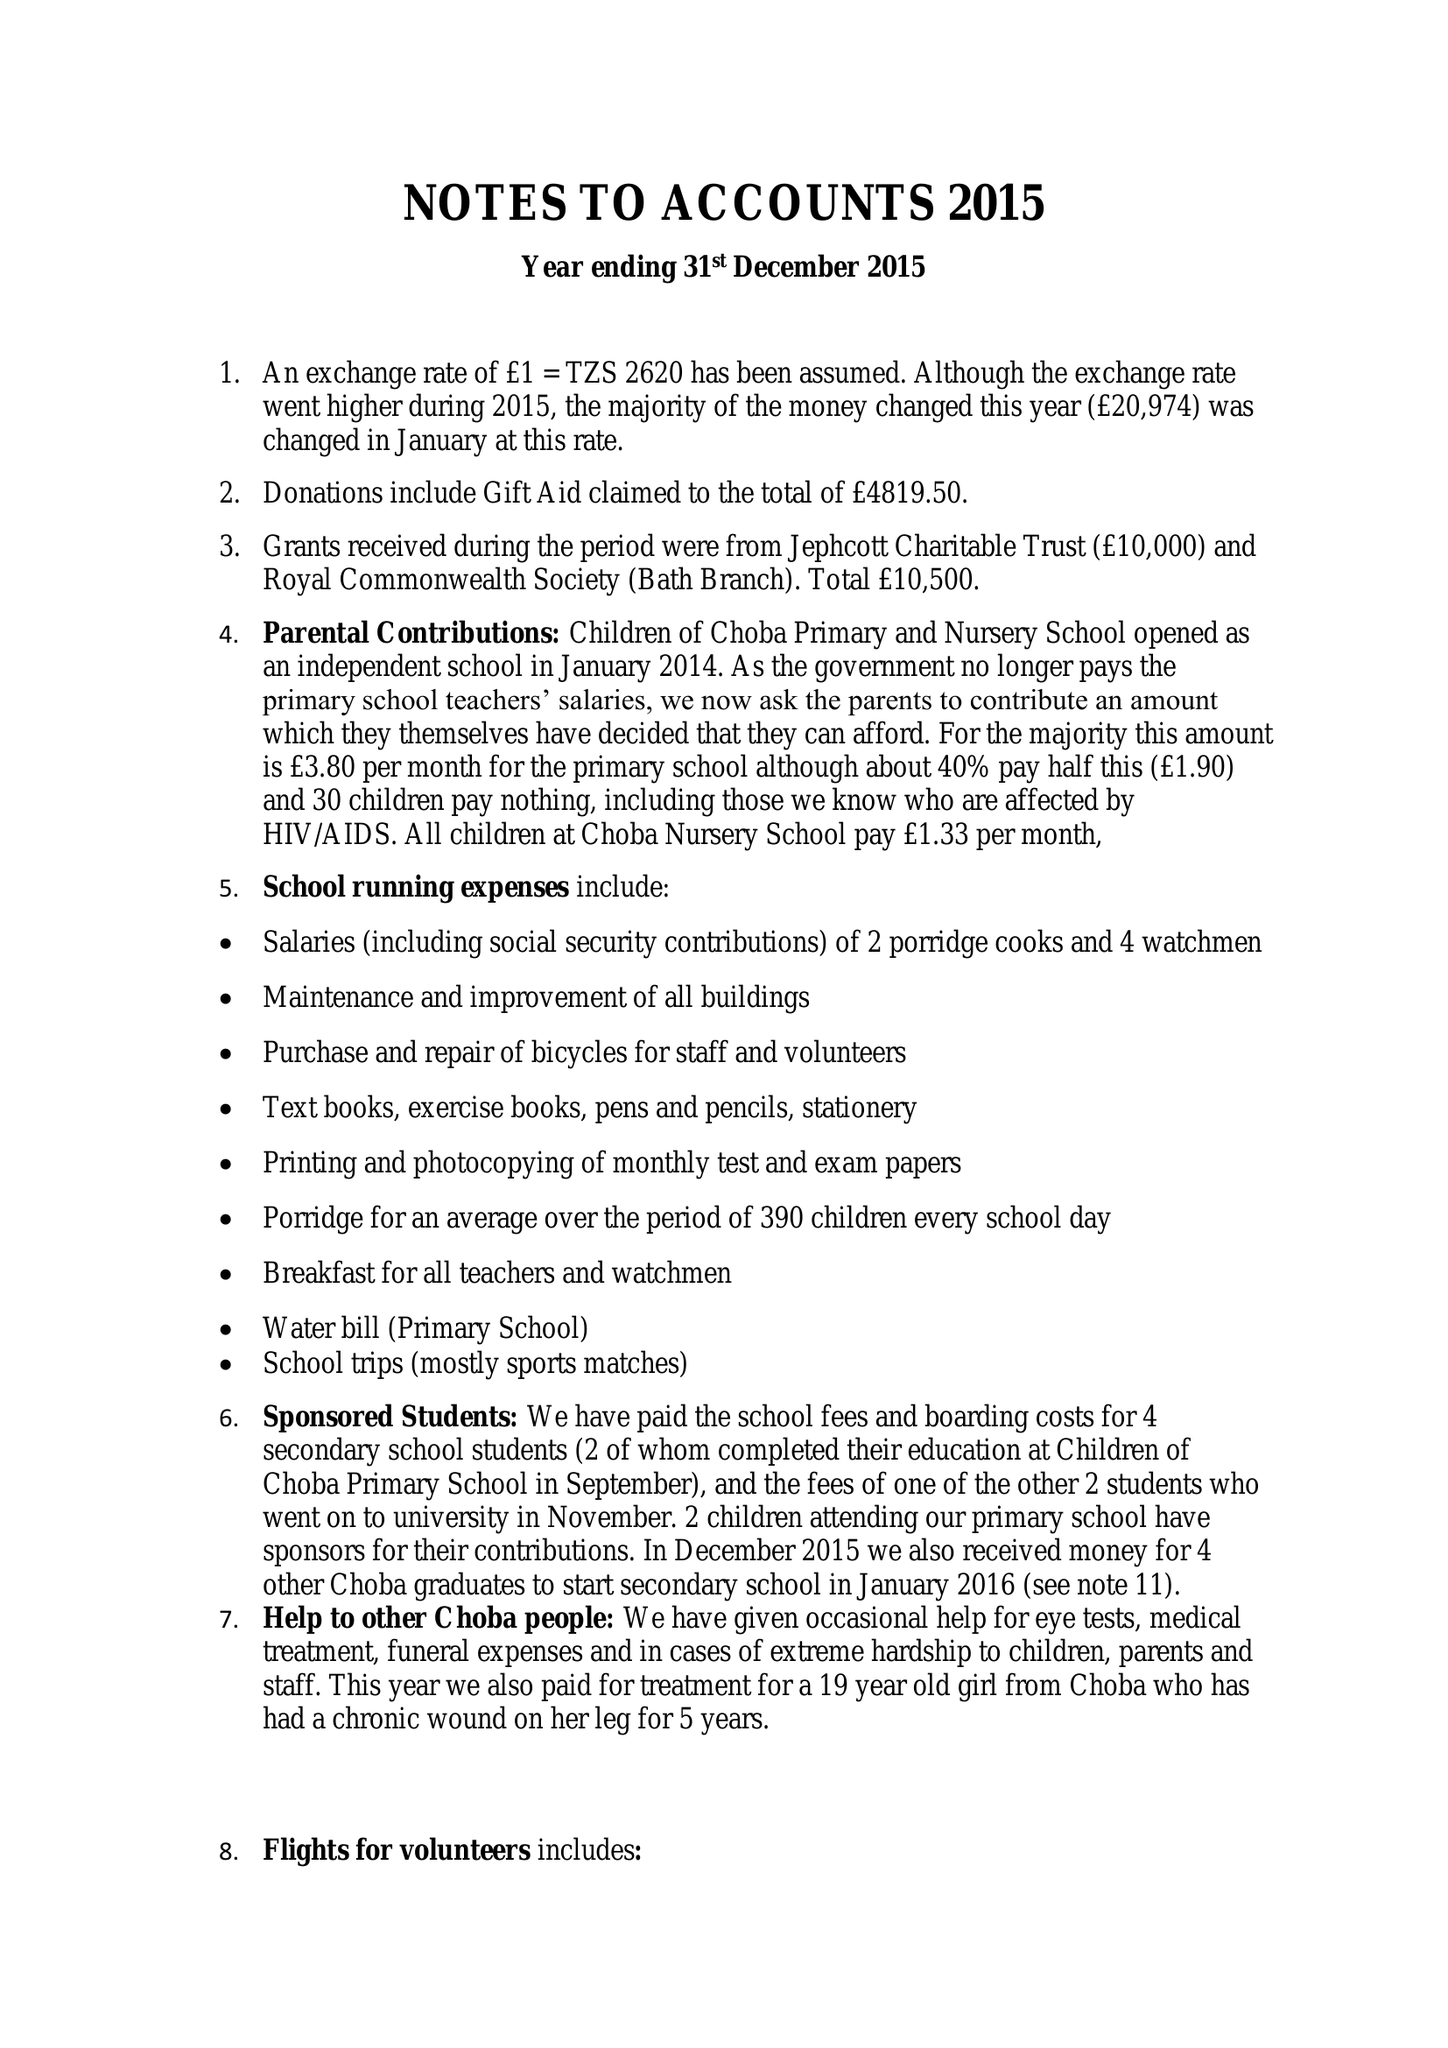What is the value for the charity_name?
Answer the question using a single word or phrase. Children Of Choba 